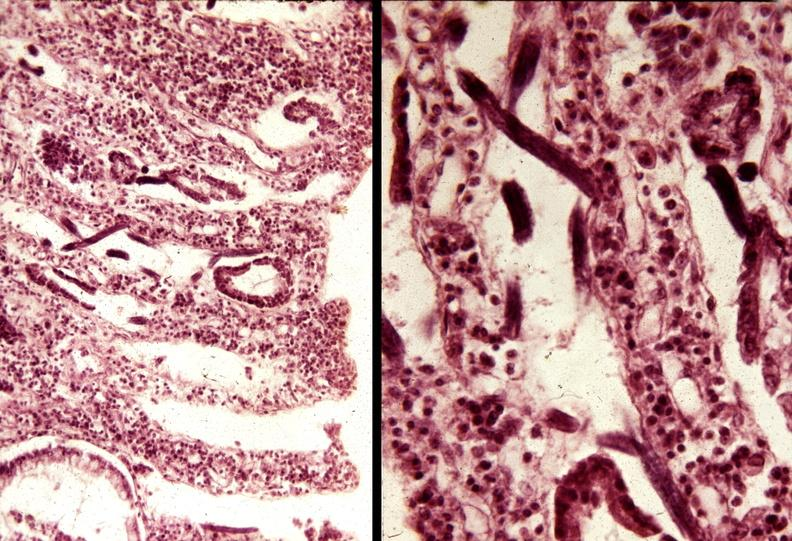what does this image show?
Answer the question using a single word or phrase. Colon 